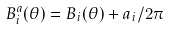Convert formula to latex. <formula><loc_0><loc_0><loc_500><loc_500>B ^ { a } _ { i } ( \theta ) = B _ { i } ( \theta ) + a _ { i } / 2 \pi</formula> 